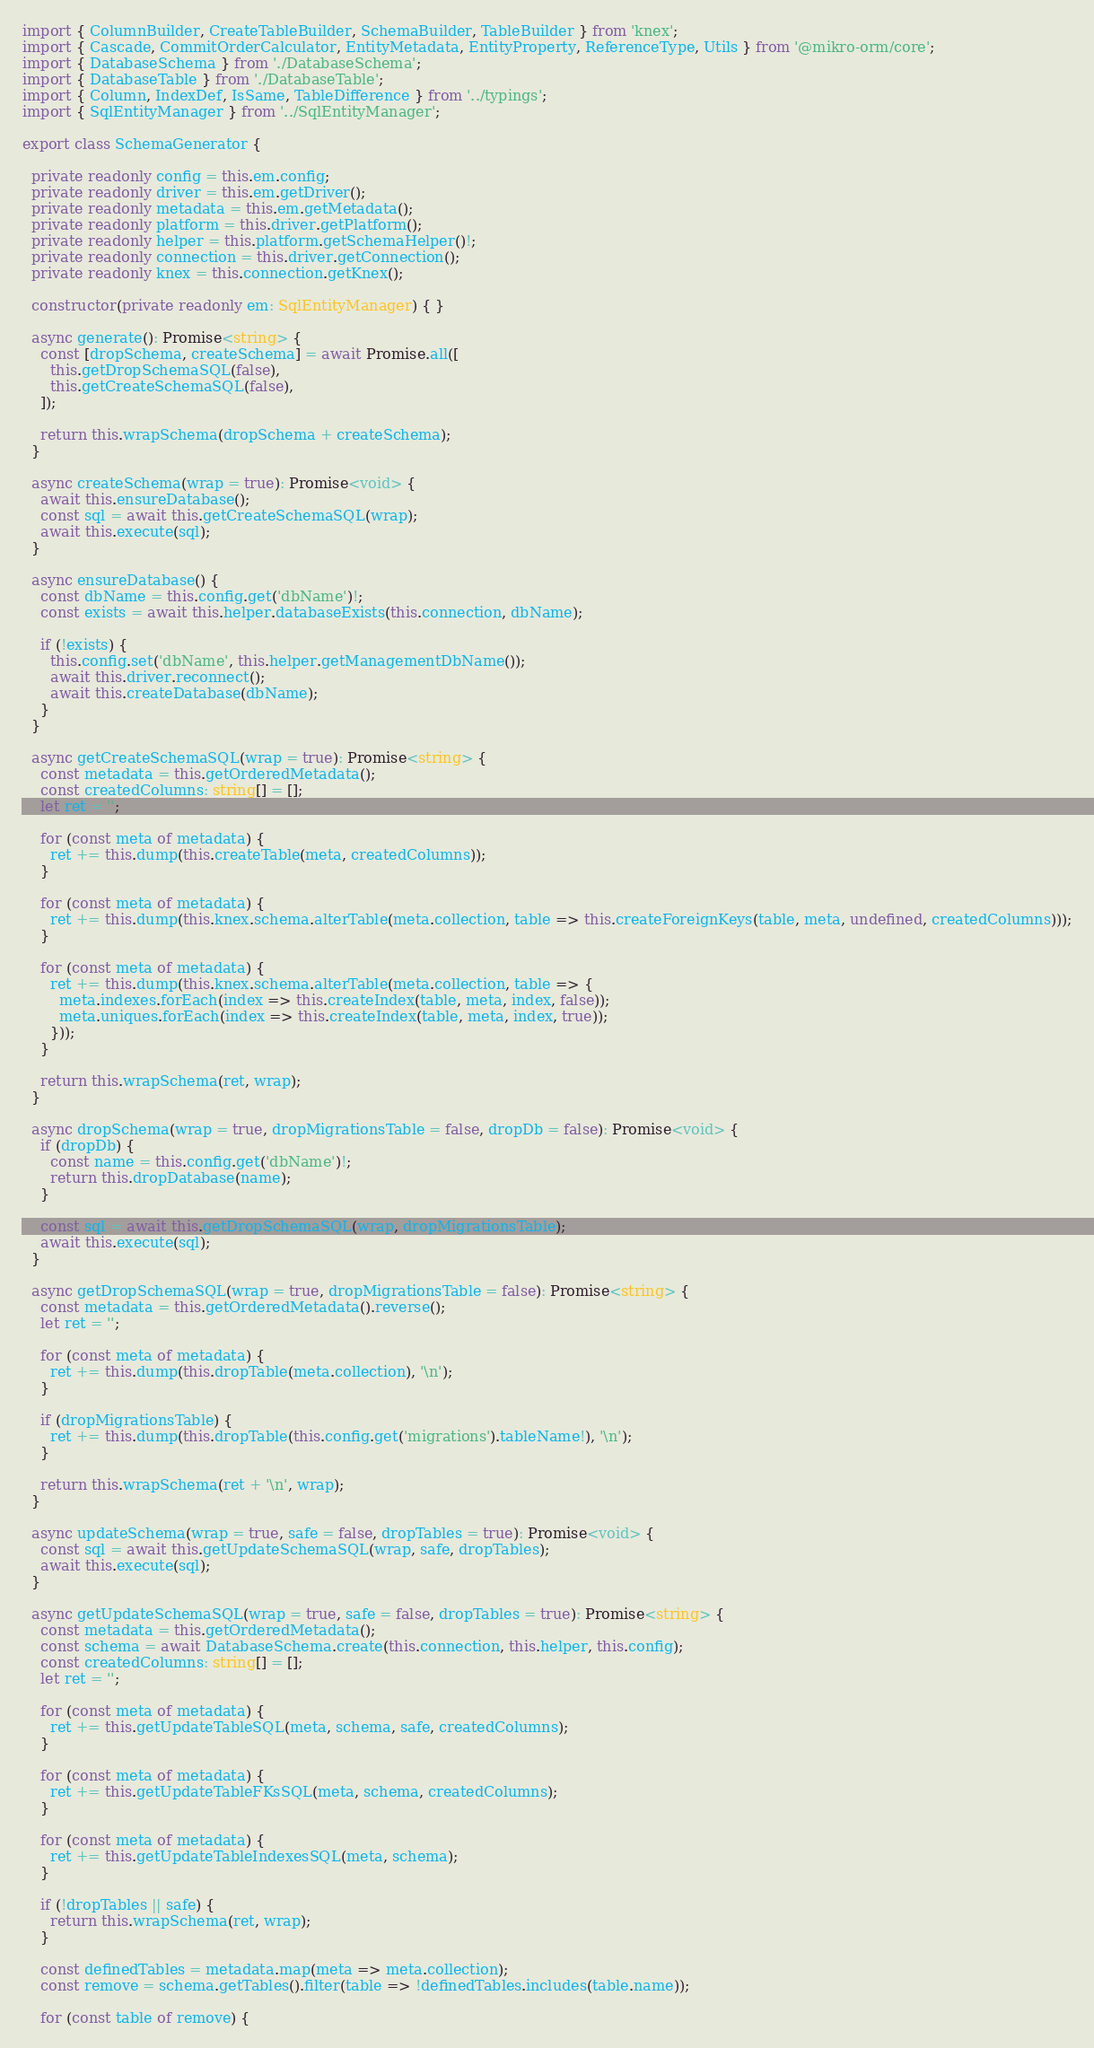Convert code to text. <code><loc_0><loc_0><loc_500><loc_500><_TypeScript_>import { ColumnBuilder, CreateTableBuilder, SchemaBuilder, TableBuilder } from 'knex';
import { Cascade, CommitOrderCalculator, EntityMetadata, EntityProperty, ReferenceType, Utils } from '@mikro-orm/core';
import { DatabaseSchema } from './DatabaseSchema';
import { DatabaseTable } from './DatabaseTable';
import { Column, IndexDef, IsSame, TableDifference } from '../typings';
import { SqlEntityManager } from '../SqlEntityManager';

export class SchemaGenerator {

  private readonly config = this.em.config;
  private readonly driver = this.em.getDriver();
  private readonly metadata = this.em.getMetadata();
  private readonly platform = this.driver.getPlatform();
  private readonly helper = this.platform.getSchemaHelper()!;
  private readonly connection = this.driver.getConnection();
  private readonly knex = this.connection.getKnex();

  constructor(private readonly em: SqlEntityManager) { }

  async generate(): Promise<string> {
    const [dropSchema, createSchema] = await Promise.all([
      this.getDropSchemaSQL(false),
      this.getCreateSchemaSQL(false),
    ]);

    return this.wrapSchema(dropSchema + createSchema);
  }

  async createSchema(wrap = true): Promise<void> {
    await this.ensureDatabase();
    const sql = await this.getCreateSchemaSQL(wrap);
    await this.execute(sql);
  }

  async ensureDatabase() {
    const dbName = this.config.get('dbName')!;
    const exists = await this.helper.databaseExists(this.connection, dbName);

    if (!exists) {
      this.config.set('dbName', this.helper.getManagementDbName());
      await this.driver.reconnect();
      await this.createDatabase(dbName);
    }
  }

  async getCreateSchemaSQL(wrap = true): Promise<string> {
    const metadata = this.getOrderedMetadata();
    const createdColumns: string[] = [];
    let ret = '';

    for (const meta of metadata) {
      ret += this.dump(this.createTable(meta, createdColumns));
    }

    for (const meta of metadata) {
      ret += this.dump(this.knex.schema.alterTable(meta.collection, table => this.createForeignKeys(table, meta, undefined, createdColumns)));
    }

    for (const meta of metadata) {
      ret += this.dump(this.knex.schema.alterTable(meta.collection, table => {
        meta.indexes.forEach(index => this.createIndex(table, meta, index, false));
        meta.uniques.forEach(index => this.createIndex(table, meta, index, true));
      }));
    }

    return this.wrapSchema(ret, wrap);
  }

  async dropSchema(wrap = true, dropMigrationsTable = false, dropDb = false): Promise<void> {
    if (dropDb) {
      const name = this.config.get('dbName')!;
      return this.dropDatabase(name);
    }

    const sql = await this.getDropSchemaSQL(wrap, dropMigrationsTable);
    await this.execute(sql);
  }

  async getDropSchemaSQL(wrap = true, dropMigrationsTable = false): Promise<string> {
    const metadata = this.getOrderedMetadata().reverse();
    let ret = '';

    for (const meta of metadata) {
      ret += this.dump(this.dropTable(meta.collection), '\n');
    }

    if (dropMigrationsTable) {
      ret += this.dump(this.dropTable(this.config.get('migrations').tableName!), '\n');
    }

    return this.wrapSchema(ret + '\n', wrap);
  }

  async updateSchema(wrap = true, safe = false, dropTables = true): Promise<void> {
    const sql = await this.getUpdateSchemaSQL(wrap, safe, dropTables);
    await this.execute(sql);
  }

  async getUpdateSchemaSQL(wrap = true, safe = false, dropTables = true): Promise<string> {
    const metadata = this.getOrderedMetadata();
    const schema = await DatabaseSchema.create(this.connection, this.helper, this.config);
    const createdColumns: string[] = [];
    let ret = '';

    for (const meta of metadata) {
      ret += this.getUpdateTableSQL(meta, schema, safe, createdColumns);
    }

    for (const meta of metadata) {
      ret += this.getUpdateTableFKsSQL(meta, schema, createdColumns);
    }

    for (const meta of metadata) {
      ret += this.getUpdateTableIndexesSQL(meta, schema);
    }

    if (!dropTables || safe) {
      return this.wrapSchema(ret, wrap);
    }

    const definedTables = metadata.map(meta => meta.collection);
    const remove = schema.getTables().filter(table => !definedTables.includes(table.name));

    for (const table of remove) {</code> 